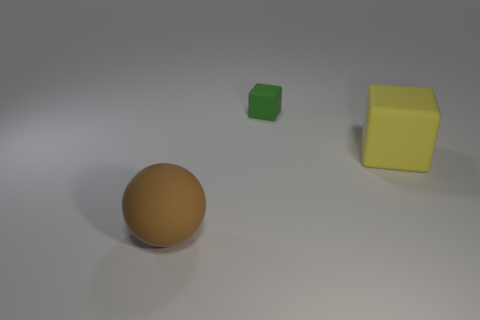Is there anything else that has the same shape as the big brown matte object?
Your answer should be compact. No. What shape is the rubber thing that is behind the matte ball and in front of the green rubber cube?
Provide a short and direct response. Cube. There is a brown rubber ball; does it have the same size as the block that is in front of the tiny object?
Ensure brevity in your answer.  Yes. There is another thing that is the same shape as the green rubber thing; what is its color?
Keep it short and to the point. Yellow. Does the rubber thing in front of the yellow rubber block have the same size as the block in front of the tiny green cube?
Make the answer very short. Yes. Does the yellow object have the same shape as the small rubber object?
Your answer should be very brief. Yes. What number of objects are either large matte blocks that are to the right of the large brown matte ball or small green cubes?
Your answer should be compact. 2. Is there another rubber object of the same shape as the big yellow matte thing?
Offer a terse response. Yes. Is the number of green matte things in front of the large matte sphere the same as the number of large yellow things?
Provide a short and direct response. No. How many yellow matte cubes are the same size as the green rubber block?
Provide a short and direct response. 0. 